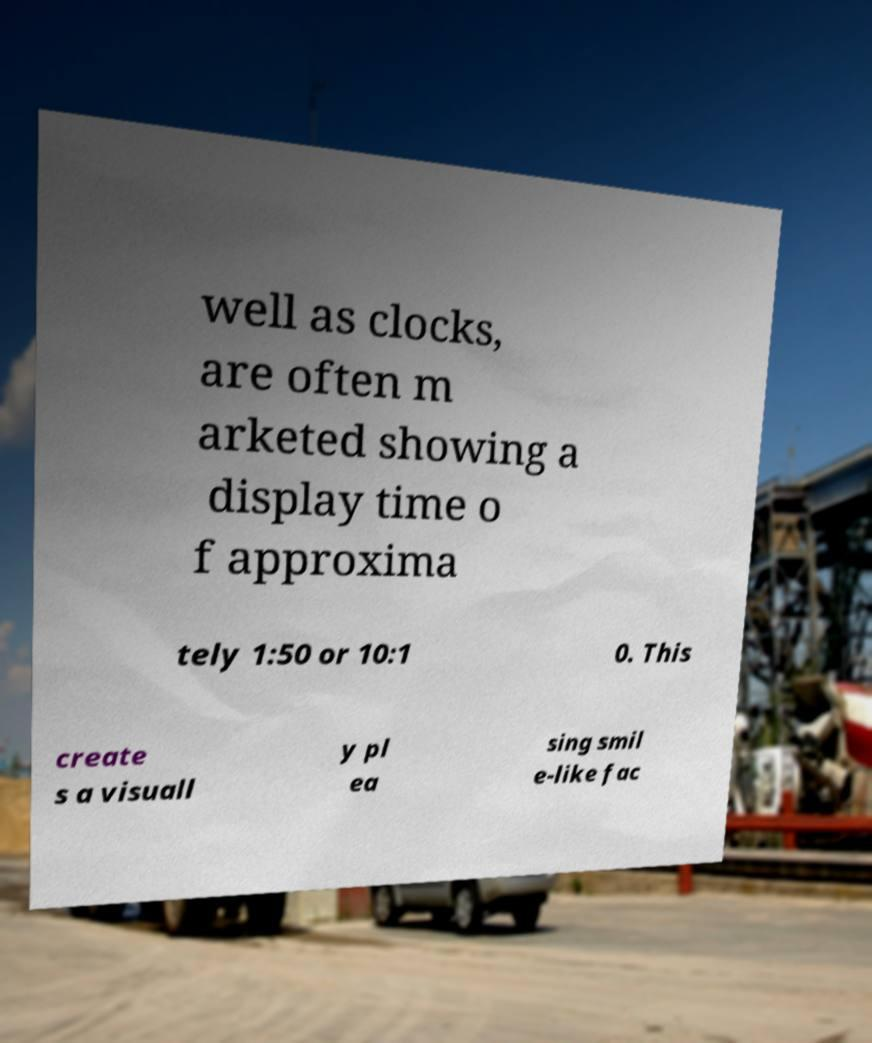Could you assist in decoding the text presented in this image and type it out clearly? well as clocks, are often m arketed showing a display time o f approxima tely 1:50 or 10:1 0. This create s a visuall y pl ea sing smil e-like fac 